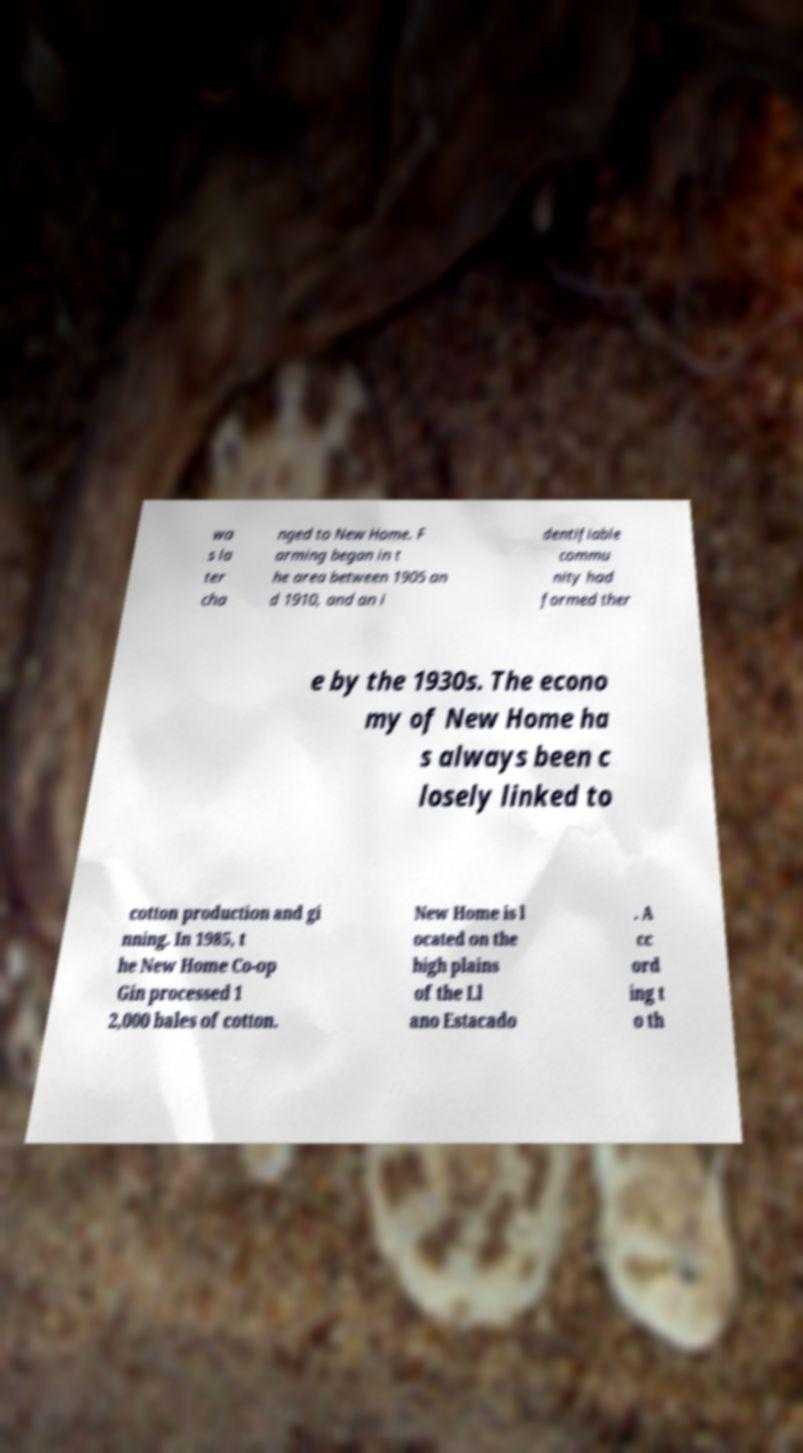I need the written content from this picture converted into text. Can you do that? wa s la ter cha nged to New Home. F arming began in t he area between 1905 an d 1910, and an i dentifiable commu nity had formed ther e by the 1930s. The econo my of New Home ha s always been c losely linked to cotton production and gi nning. In 1985, t he New Home Co-op Gin processed 1 2,000 bales of cotton. New Home is l ocated on the high plains of the Ll ano Estacado . A cc ord ing t o th 